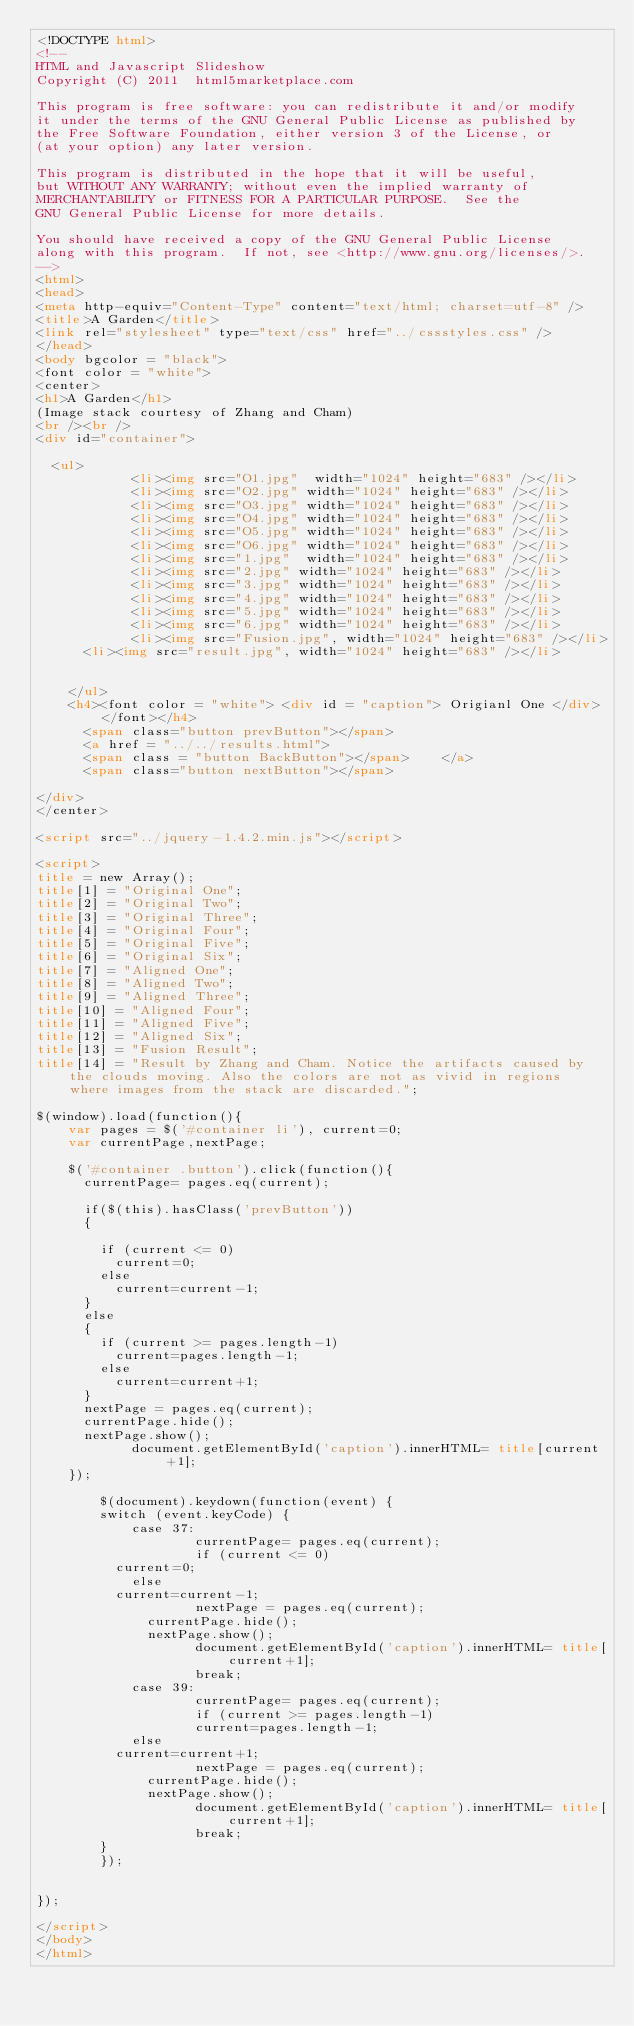<code> <loc_0><loc_0><loc_500><loc_500><_HTML_><!DOCTYPE html>
<!--
HTML and Javascript Slideshow
Copyright (C) 2011  html5marketplace.com

This program is free software: you can redistribute it and/or modify
it under the terms of the GNU General Public License as published by
the Free Software Foundation, either version 3 of the License, or
(at your option) any later version.

This program is distributed in the hope that it will be useful,
but WITHOUT ANY WARRANTY; without even the implied warranty of
MERCHANTABILITY or FITNESS FOR A PARTICULAR PURPOSE.  See the
GNU General Public License for more details.

You should have received a copy of the GNU General Public License
along with this program.  If not, see <http://www.gnu.org/licenses/>.
-->
<html>
<head>
<meta http-equiv="Content-Type" content="text/html; charset=utf-8" />
<title>A Garden</title>
<link rel="stylesheet" type="text/css" href="../cssstyles.css" />
</head>
<body bgcolor = "black">
<font color = "white">
<center>
<h1>A Garden</h1>
(Image stack courtesy of Zhang and Cham)
<br /><br />
<div id="container">

	<ul>
      	    <li><img src="O1.jpg"  width="1024" height="683" /></li>
            <li><img src="O2.jpg" width="1024" height="683" /></li>
            <li><img src="O3.jpg" width="1024" height="683" /></li>
            <li><img src="O4.jpg" width="1024" height="683" /></li>            
            <li><img src="O5.jpg" width="1024" height="683" /></li>
            <li><img src="O6.jpg" width="1024" height="683" /></li>            
      	    <li><img src="1.jpg"  width="1024" height="683" /></li>
            <li><img src="2.jpg" width="1024" height="683" /></li>
            <li><img src="3.jpg" width="1024" height="683" /></li>
            <li><img src="4.jpg" width="1024" height="683" /></li>            
            <li><img src="5.jpg" width="1024" height="683" /></li>
            <li><img src="6.jpg" width="1024" height="683" /></li>             
            <li><img src="Fusion.jpg", width="1024" height="683" /></li>
			<li><img src="result.jpg", width="1024" height="683" /></li>
			
			
    </ul>            
    <h4><font color = "white"> <div id = "caption"> Origianl One </div> </font></h4>            
      <span class="button prevButton"></span>
      <a href = "../../results.html"> 
      <span class = "button BackButton"></span>    </a>  
      <span class="button nextButton"></span>

</div>
</center>

<script src="../jquery-1.4.2.min.js"></script>

<script>
title = new Array();
title[1] = "Original One";
title[2] = "Original Two";
title[3] = "Original Three";
title[4] = "Original Four";
title[5] = "Original Five";
title[6] = "Original Six";
title[7] = "Aligned One";
title[8] = "Aligned Two";
title[9] = "Aligned Three";
title[10] = "Aligned Four";
title[11] = "Aligned Five";
title[12] = "Aligned Six";
title[13] = "Fusion Result";
title[14] = "Result by Zhang and Cham. Notice the artifacts caused by the clouds moving. Also the colors are not as vivid in regions where images from the stack are discarded.";

$(window).load(function(){
		var pages = $('#container li'), current=0;
		var currentPage,nextPage;

		$('#container .button').click(function(){
			currentPage= pages.eq(current);
            
			if($(this).hasClass('prevButton'))
			{

				if (current <= 0)
					current=0;
				else
					current=current-1;
			}
			else
			{
				if (current >= pages.length-1)
					current=pages.length-1;
				else
					current=current+1;
			}
			nextPage = pages.eq(current);	            
			currentPage.hide();	
			nextPage.show();
            document.getElementById('caption').innerHTML= title[current+1];
		});
        
        $(document).keydown(function(event) {
        switch (event.keyCode) {
            case 37: 
                    currentPage= pages.eq(current);
                    if (current <= 0)
					current=0;
				    else
					current=current-1;
                    nextPage = pages.eq(current);	
			        currentPage.hide();	
			        nextPage.show(); 
                    document.getElementById('caption').innerHTML= title[current+1];
                    break;
            case 39: 
                    currentPage= pages.eq(current);
                    if (current >= pages.length-1)
                    current=pages.length-1;
	    			else
					current=current+1;
                    nextPage = pages.eq(current);	
			        currentPage.hide();	
			        nextPage.show();
                    document.getElementById('caption').innerHTML= title[current+1];                    
                    break;
        }
        });

        
});

</script>
</body>
</html>
</code> 